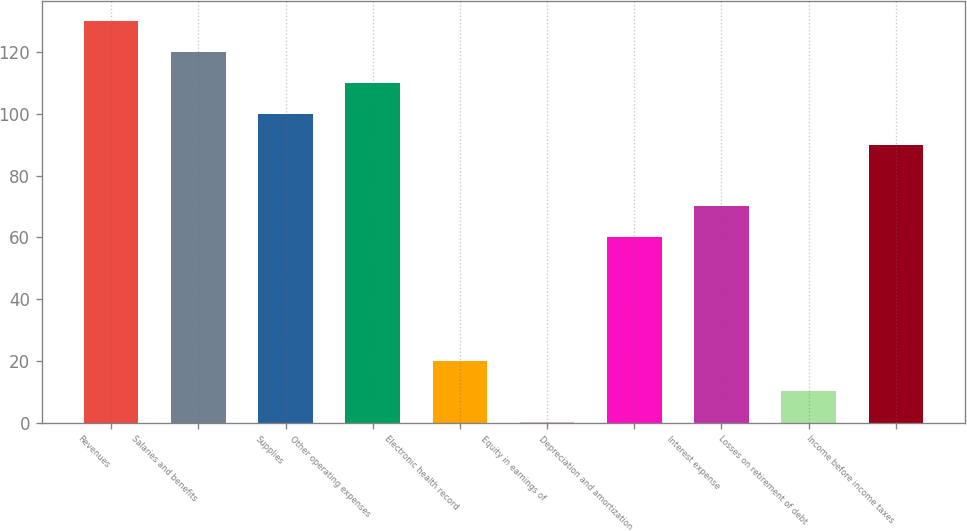Convert chart to OTSL. <chart><loc_0><loc_0><loc_500><loc_500><bar_chart><fcel>Revenues<fcel>Salaries and benefits<fcel>Supplies<fcel>Other operating expenses<fcel>Electronic health record<fcel>Equity in earnings of<fcel>Depreciation and amortization<fcel>Interest expense<fcel>Losses on retirement of debt<fcel>Income before income taxes<nl><fcel>129.97<fcel>119.98<fcel>100<fcel>109.99<fcel>20.08<fcel>0.1<fcel>60.04<fcel>70.03<fcel>10.09<fcel>90.01<nl></chart> 